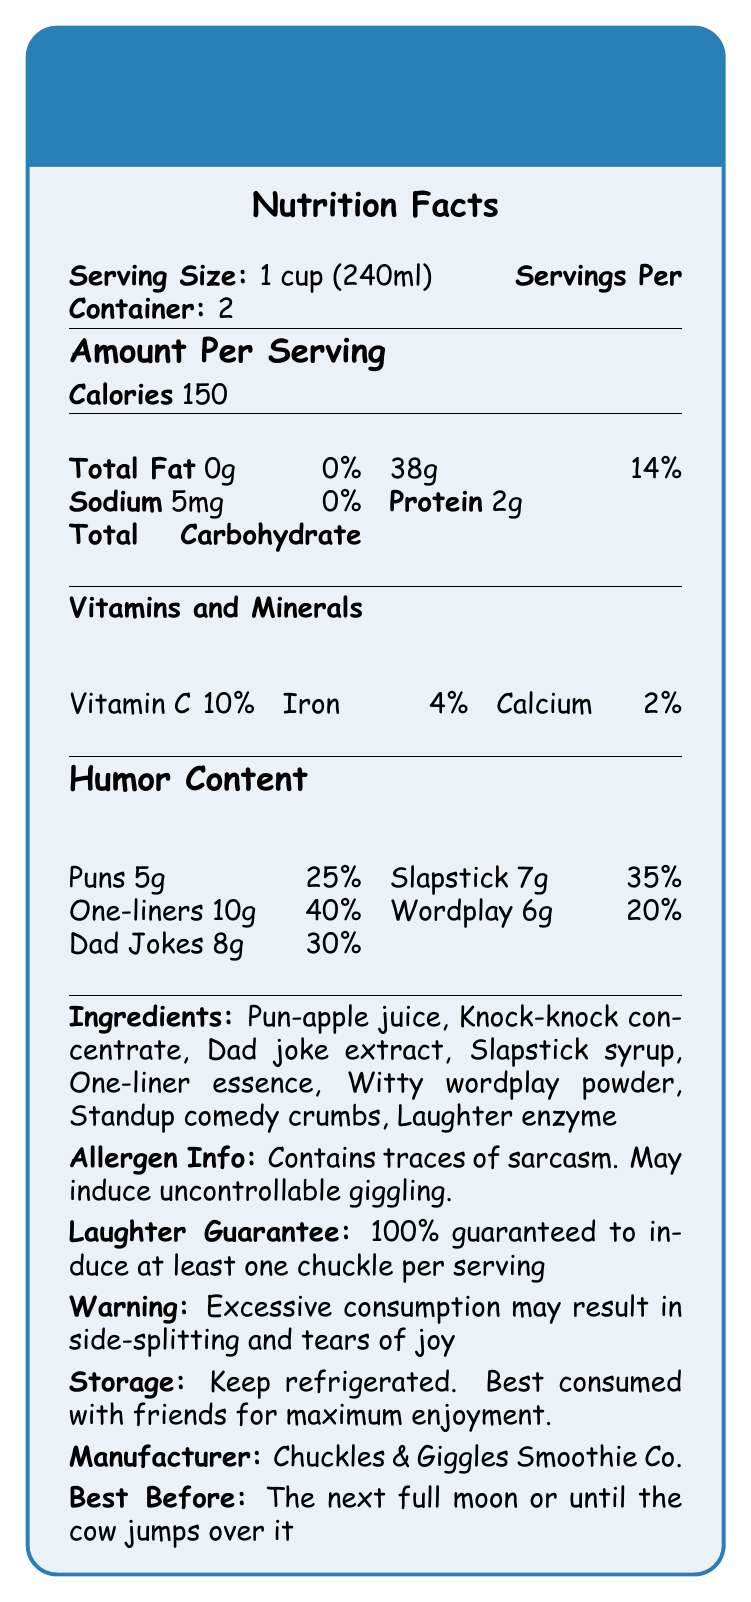Who is the manufacturer of Jokester's Laughter Smoothie? The document states under the storage instructions that the manufacturer is Chuckles & Giggles Smoothie Co.
Answer: Chuckles & Giggles Smoothie Co. How many calories are there per serving? It is mentioned in the amount per serving section that each serving has 150 calories.
Answer: 150 What is the serving size of Jokester's Laughter Smoothie? The serving size is clearly indicated at the beginning of the document as 1 cup (240ml).
Answer: 1 cup (240ml) List three vitamins/minerals included in the smoothie and their daily values. The document specifies under the Vitamins and Minerals section that it includes 10% of Vitamin C, 4% of Iron, and 2% of Calcium daily values.
Answer: Vitamin C 10%, Iron 4%, Calcium 2% How much sodium is in one serving of Jokester's Laughter Smoothie? The amount of sodium in one serving is specified as 5mg in the document.
Answer: 5mg Which of the following is NOT an ingredient in Jokester's Laughter Smoothie? A. Pun-apple juice B. Knock-knock concentrate C. Hilarious hops D. Dad joke extract The list of ingredients includes Pun-apple juice, Knock-knock concentrate, and Dad joke extract, but not Hilarious hops.
Answer: C. Hilarious hops What is the best before date for this smoothie? A. Next New Year B. The next full moon C. Until the cow jumps over the moon D. Both B and C The document specifies the best before date as either the next full moon or until the cow jumps over it.
Answer: D. Both B and C Are there any allergens in Jokester's Laughter Smoothie? The allergen info section informs us that the smoothie contains traces of sarcasm and may induce uncontrollable giggling.
Answer: Yes Does the Laughter Smoothie guarantee to induce at least one chuckle per serving? The Laughter Guarantee section of the document states that there is a 100% guarantee to induce at least one chuckle per serving.
Answer: Yes Summarize the main idea of the Jokester's Laughter Smoothie Nutrition Facts Label. The document provides detailed nutritional facts, humor content, ingredients, allergen info, storage instructions, and guarantees that align with the comedic theme of the product.
Answer: Jokester's Laughter Smoothie is a humorous product rich in different types of jokes. It offers nutritional information like calories, fats, vitamins, minerals, and humor content. It guarantees at least one chuckle per serving and should be kept refrigerated. The manufacturer is Chuckles & Giggles Smoothie Co. How can excessive consumption of the Laughter Smoothie affect you? The warning section clearly states that excessive consumption could lead to side-splitting and tears of joy.
Answer: It may result in side-splitting and tears of joy. How many grams of puns are there in one serving? The humor content section mentions that each serving contains 5g of puns.
Answer: 5g Is there any wordplay in the ingredients list? The ingredients include wordplay such as "Pun-apple juice", "Knock-knock concentrate", "Dad joke extract", "Slapstick syrup", "One-liner essence", "Witty wordplay powder", "Standup comedy crumbs", and "Laughter enzyme."
Answer: Yes List the five types of humor content and their amounts per serving. The humor content section describes the amounts of puns, one-liners, dad jokes, slapstick, and wordplay per serving.
Answer: Puns 5g, One-liners 10g, Dad Jokes 8g, Slapstick 7g, Wordplay 6g What is the total daily value percentage of humor in Jokester's Laughter Smoothie per serving? The document does not provide a cumulative daily value for humor content per serving; it only provides individual percentages for each type of humor.
Answer: Cannot be determined 